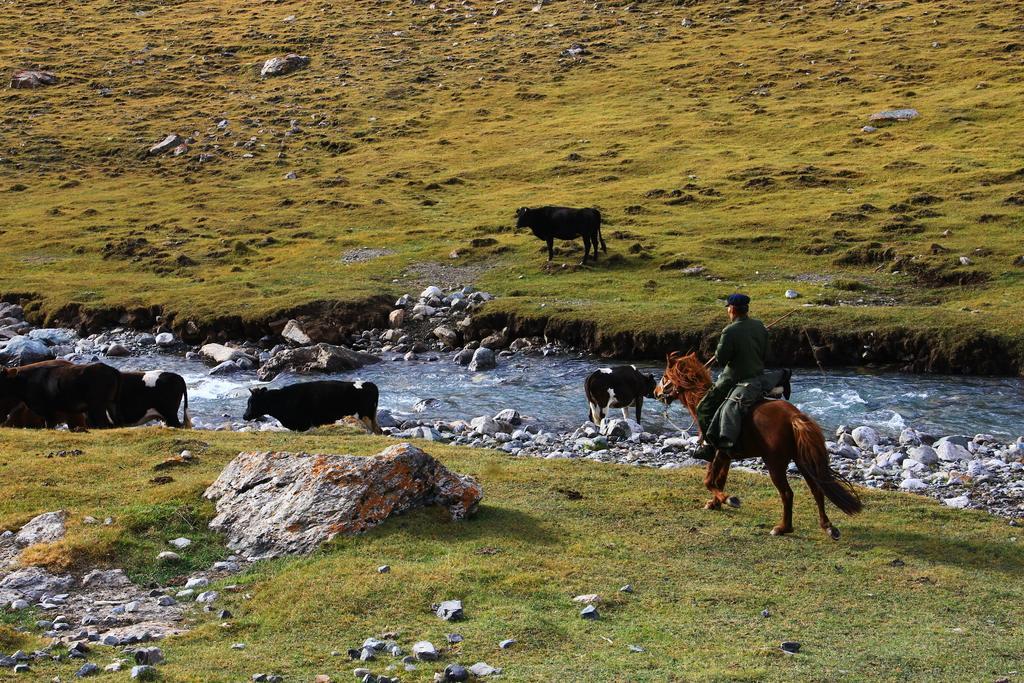Can you describe this image briefly? In this image I can see a brown color horse and person is sitting on it. He is wearing green color dress and a cap. Back I can see few animals. They are in black and white color. I can see few stones,water and green color grass. 